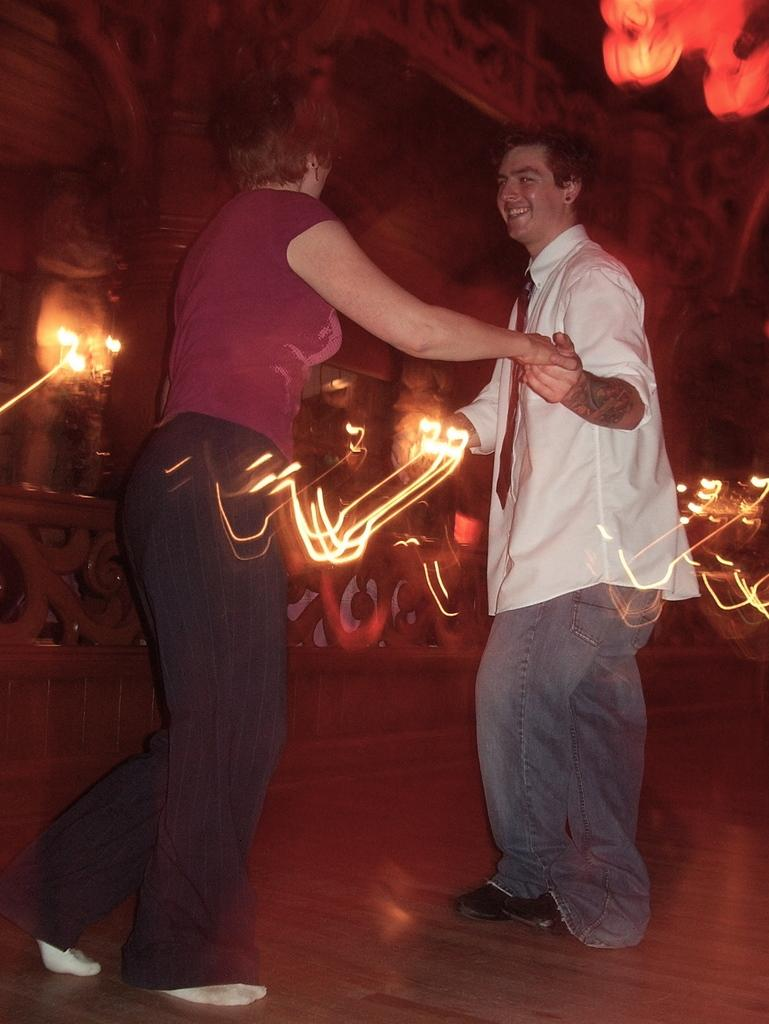How many people are in the image? There are two people in the image. What are the two people doing in the image? The two people are dancing on the floor. What can be seen in the background of the image? There is a wall with lights in the background of the image. What type of haircut does the farmer have in the image? There is no farmer present in the image, and therefore no haircut can be observed. What kind of ray is visible in the image? There is no ray visible in the image. 